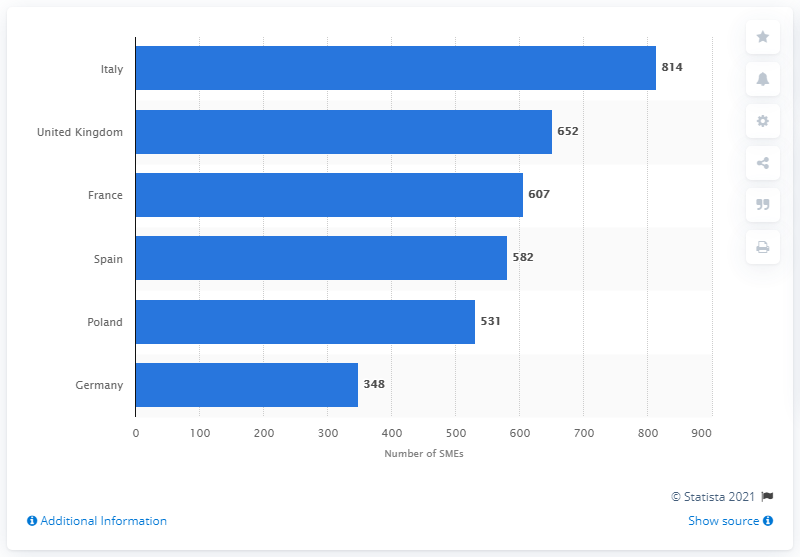Indicate a few pertinent items in this graphic. In 2019, France had 607 cosmetic manufacturing small and medium enterprises. In 2019, the cosmetics manufacturing industry in the UK was home to 652 small and medium enterprises. There were 814 small and medium-sized enterprises in the cosmetics manufacturing industry in Italy in 2019. 